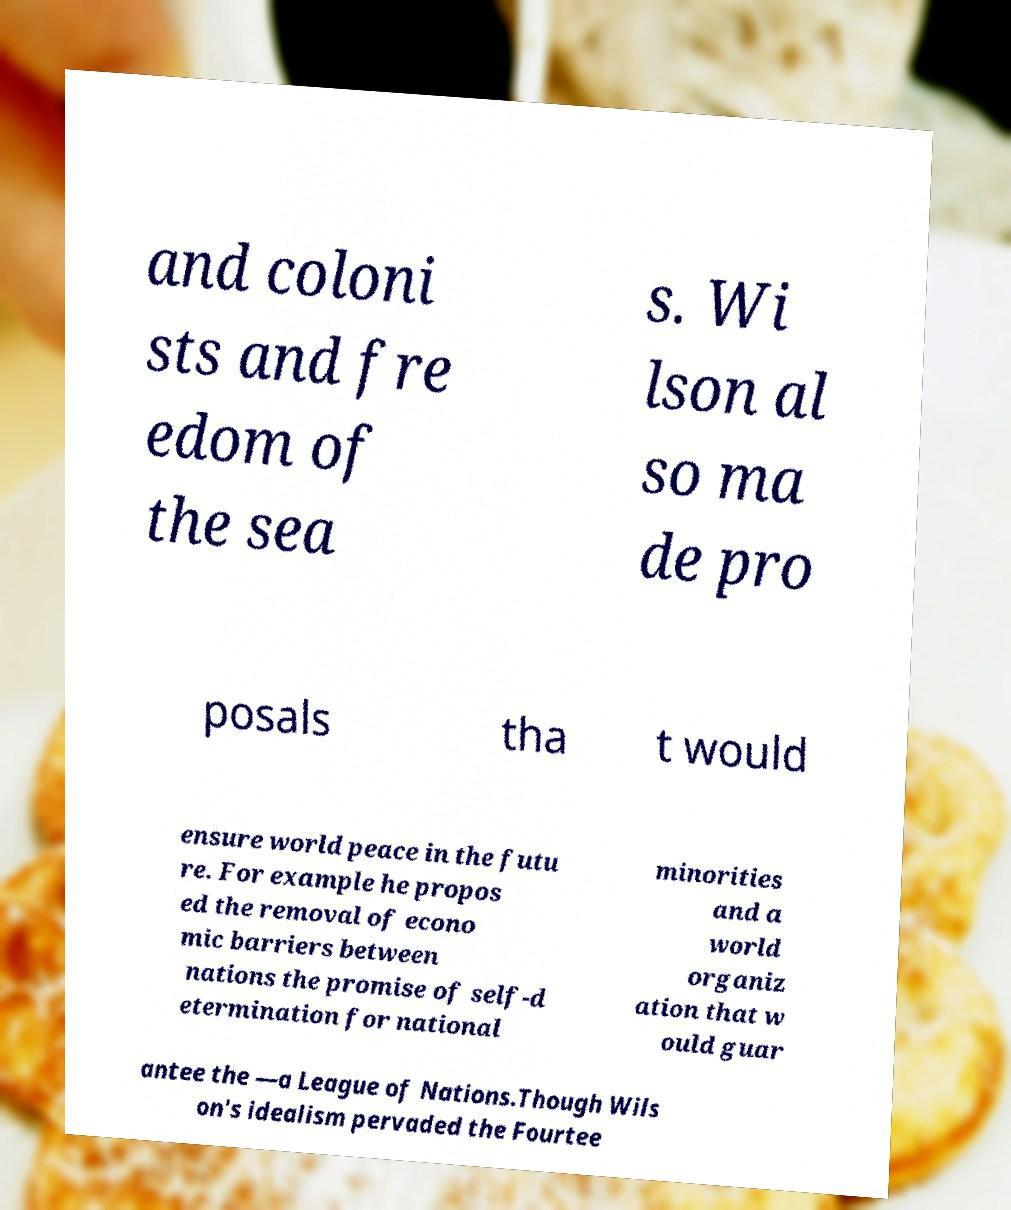There's text embedded in this image that I need extracted. Can you transcribe it verbatim? and coloni sts and fre edom of the sea s. Wi lson al so ma de pro posals tha t would ensure world peace in the futu re. For example he propos ed the removal of econo mic barriers between nations the promise of self-d etermination for national minorities and a world organiz ation that w ould guar antee the —a League of Nations.Though Wils on's idealism pervaded the Fourtee 